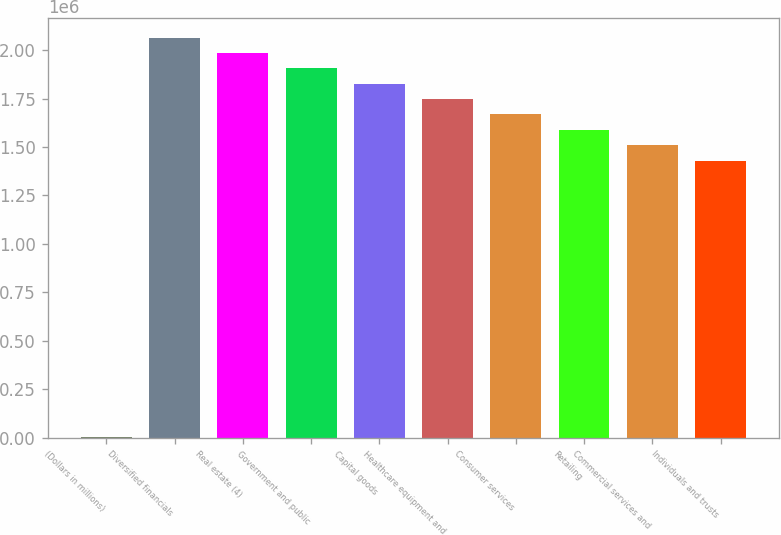Convert chart to OTSL. <chart><loc_0><loc_0><loc_500><loc_500><bar_chart><fcel>(Dollars in millions)<fcel>Diversified financials<fcel>Real estate (4)<fcel>Government and public<fcel>Capital goods<fcel>Healthcare equipment and<fcel>Consumer services<fcel>Retailing<fcel>Commercial services and<fcel>Individuals and trusts<nl><fcel>2009<fcel>2.06449e+06<fcel>1.98516e+06<fcel>1.90584e+06<fcel>1.82651e+06<fcel>1.74718e+06<fcel>1.66786e+06<fcel>1.58853e+06<fcel>1.5092e+06<fcel>1.42988e+06<nl></chart> 